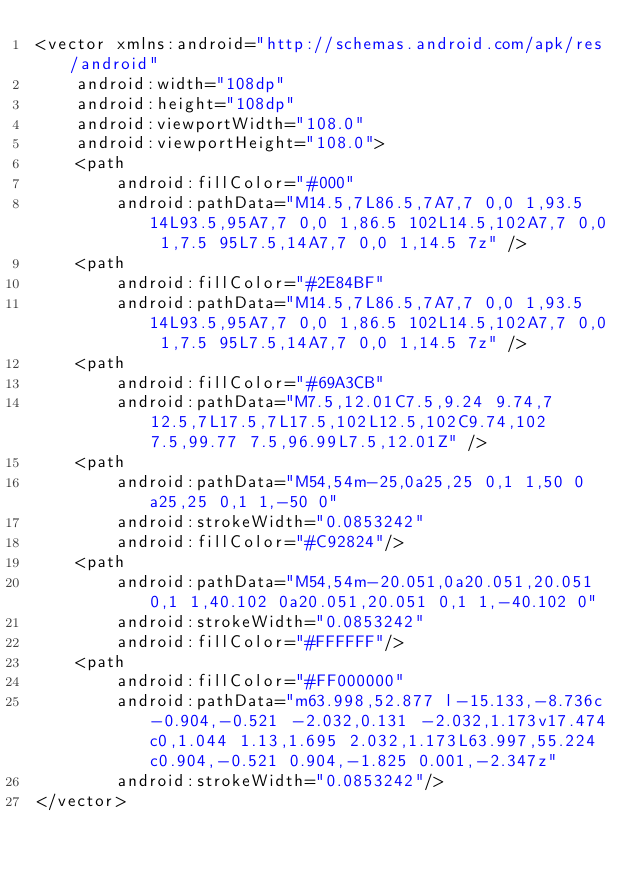Convert code to text. <code><loc_0><loc_0><loc_500><loc_500><_XML_><vector xmlns:android="http://schemas.android.com/apk/res/android"
    android:width="108dp"
    android:height="108dp"
    android:viewportWidth="108.0"
    android:viewportHeight="108.0">
    <path
        android:fillColor="#000"
        android:pathData="M14.5,7L86.5,7A7,7 0,0 1,93.5 14L93.5,95A7,7 0,0 1,86.5 102L14.5,102A7,7 0,0 1,7.5 95L7.5,14A7,7 0,0 1,14.5 7z" />
    <path
        android:fillColor="#2E84BF"
        android:pathData="M14.5,7L86.5,7A7,7 0,0 1,93.5 14L93.5,95A7,7 0,0 1,86.5 102L14.5,102A7,7 0,0 1,7.5 95L7.5,14A7,7 0,0 1,14.5 7z" />
    <path
        android:fillColor="#69A3CB"
        android:pathData="M7.5,12.01C7.5,9.24 9.74,7 12.5,7L17.5,7L17.5,102L12.5,102C9.74,102 7.5,99.77 7.5,96.99L7.5,12.01Z" />
    <path
        android:pathData="M54,54m-25,0a25,25 0,1 1,50 0a25,25 0,1 1,-50 0"
        android:strokeWidth="0.0853242"
        android:fillColor="#C92824"/>
    <path
        android:pathData="M54,54m-20.051,0a20.051,20.051 0,1 1,40.102 0a20.051,20.051 0,1 1,-40.102 0"
        android:strokeWidth="0.0853242"
        android:fillColor="#FFFFFF"/>
    <path
        android:fillColor="#FF000000"
        android:pathData="m63.998,52.877 l-15.133,-8.736c-0.904,-0.521 -2.032,0.131 -2.032,1.173v17.474c0,1.044 1.13,1.695 2.032,1.173L63.997,55.224c0.904,-0.521 0.904,-1.825 0.001,-2.347z"
        android:strokeWidth="0.0853242"/>
</vector>
</code> 